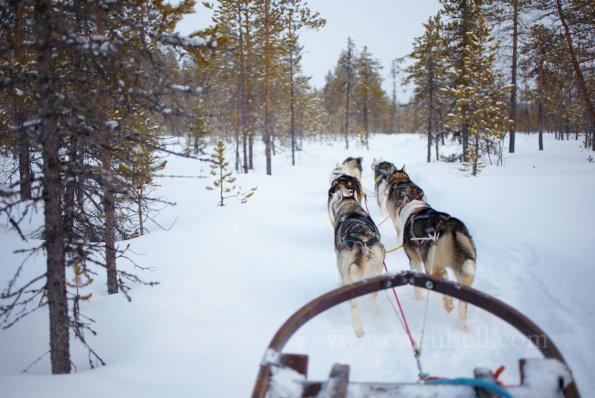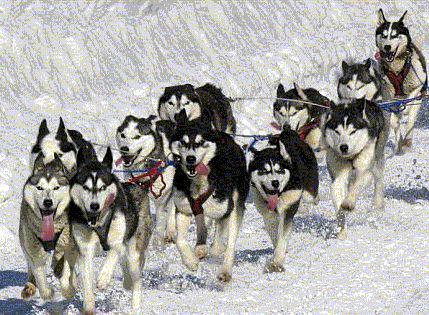The first image is the image on the left, the second image is the image on the right. Evaluate the accuracy of this statement regarding the images: "There are no trees behind the dogs in at least one of the images.". Is it true? Answer yes or no. Yes. The first image is the image on the left, the second image is the image on the right. For the images shown, is this caption "Right image shows a dog team heading rightward, with the sled and driver visible behind it." true? Answer yes or no. No. 